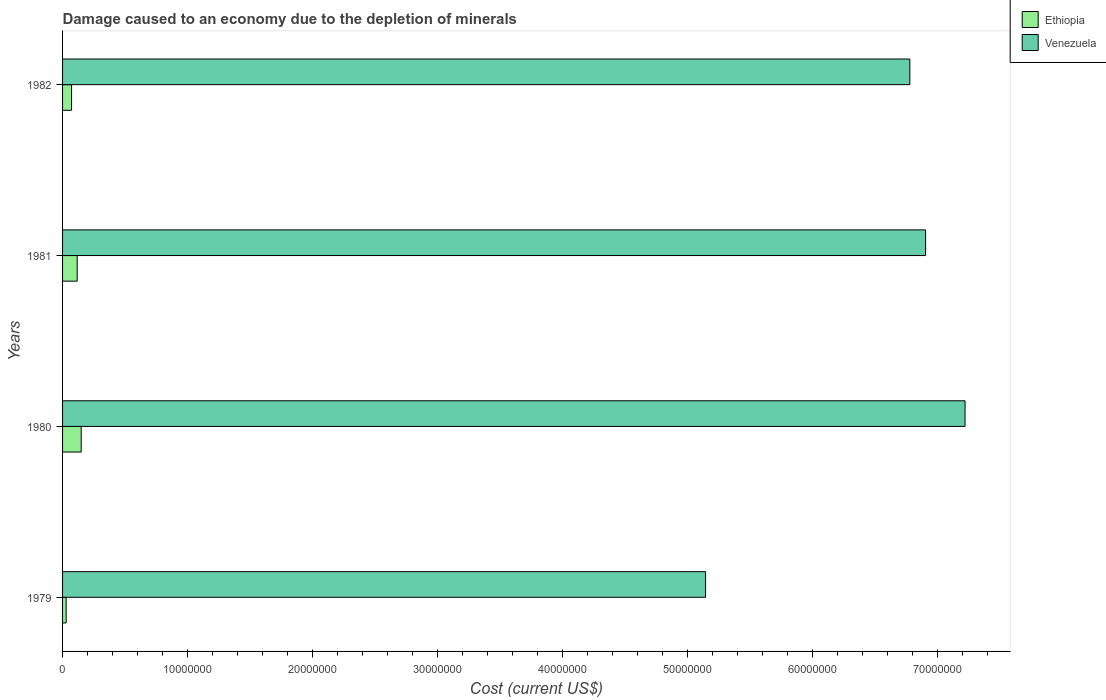Are the number of bars per tick equal to the number of legend labels?
Your response must be concise. Yes. Are the number of bars on each tick of the Y-axis equal?
Ensure brevity in your answer.  Yes. How many bars are there on the 4th tick from the top?
Ensure brevity in your answer.  2. What is the cost of damage caused due to the depletion of minerals in Venezuela in 1980?
Offer a very short reply. 7.22e+07. Across all years, what is the maximum cost of damage caused due to the depletion of minerals in Ethiopia?
Offer a terse response. 1.49e+06. Across all years, what is the minimum cost of damage caused due to the depletion of minerals in Venezuela?
Make the answer very short. 5.15e+07. In which year was the cost of damage caused due to the depletion of minerals in Venezuela minimum?
Give a very brief answer. 1979. What is the total cost of damage caused due to the depletion of minerals in Ethiopia in the graph?
Make the answer very short. 3.67e+06. What is the difference between the cost of damage caused due to the depletion of minerals in Venezuela in 1979 and that in 1980?
Offer a very short reply. -2.08e+07. What is the difference between the cost of damage caused due to the depletion of minerals in Ethiopia in 1979 and the cost of damage caused due to the depletion of minerals in Venezuela in 1980?
Offer a very short reply. -7.19e+07. What is the average cost of damage caused due to the depletion of minerals in Ethiopia per year?
Give a very brief answer. 9.18e+05. In the year 1982, what is the difference between the cost of damage caused due to the depletion of minerals in Venezuela and cost of damage caused due to the depletion of minerals in Ethiopia?
Offer a terse response. 6.71e+07. In how many years, is the cost of damage caused due to the depletion of minerals in Ethiopia greater than 62000000 US$?
Your answer should be very brief. 0. What is the ratio of the cost of damage caused due to the depletion of minerals in Ethiopia in 1980 to that in 1982?
Your answer should be very brief. 2.07. What is the difference between the highest and the second highest cost of damage caused due to the depletion of minerals in Venezuela?
Ensure brevity in your answer.  3.16e+06. What is the difference between the highest and the lowest cost of damage caused due to the depletion of minerals in Venezuela?
Offer a very short reply. 2.08e+07. In how many years, is the cost of damage caused due to the depletion of minerals in Venezuela greater than the average cost of damage caused due to the depletion of minerals in Venezuela taken over all years?
Provide a short and direct response. 3. What does the 1st bar from the top in 1979 represents?
Offer a terse response. Venezuela. What does the 2nd bar from the bottom in 1981 represents?
Your answer should be very brief. Venezuela. Are all the bars in the graph horizontal?
Your response must be concise. Yes. How many years are there in the graph?
Ensure brevity in your answer.  4. What is the title of the graph?
Your response must be concise. Damage caused to an economy due to the depletion of minerals. Does "Bermuda" appear as one of the legend labels in the graph?
Your response must be concise. No. What is the label or title of the X-axis?
Provide a succinct answer. Cost (current US$). What is the Cost (current US$) of Ethiopia in 1979?
Ensure brevity in your answer.  2.88e+05. What is the Cost (current US$) of Venezuela in 1979?
Provide a short and direct response. 5.15e+07. What is the Cost (current US$) in Ethiopia in 1980?
Provide a short and direct response. 1.49e+06. What is the Cost (current US$) in Venezuela in 1980?
Your response must be concise. 7.22e+07. What is the Cost (current US$) in Ethiopia in 1981?
Your response must be concise. 1.17e+06. What is the Cost (current US$) in Venezuela in 1981?
Make the answer very short. 6.91e+07. What is the Cost (current US$) in Ethiopia in 1982?
Offer a terse response. 7.20e+05. What is the Cost (current US$) in Venezuela in 1982?
Provide a short and direct response. 6.78e+07. Across all years, what is the maximum Cost (current US$) of Ethiopia?
Offer a terse response. 1.49e+06. Across all years, what is the maximum Cost (current US$) of Venezuela?
Offer a very short reply. 7.22e+07. Across all years, what is the minimum Cost (current US$) in Ethiopia?
Your answer should be very brief. 2.88e+05. Across all years, what is the minimum Cost (current US$) of Venezuela?
Offer a very short reply. 5.15e+07. What is the total Cost (current US$) in Ethiopia in the graph?
Offer a very short reply. 3.67e+06. What is the total Cost (current US$) of Venezuela in the graph?
Keep it short and to the point. 2.61e+08. What is the difference between the Cost (current US$) of Ethiopia in 1979 and that in 1980?
Give a very brief answer. -1.20e+06. What is the difference between the Cost (current US$) of Venezuela in 1979 and that in 1980?
Keep it short and to the point. -2.08e+07. What is the difference between the Cost (current US$) of Ethiopia in 1979 and that in 1981?
Offer a very short reply. -8.82e+05. What is the difference between the Cost (current US$) in Venezuela in 1979 and that in 1981?
Keep it short and to the point. -1.76e+07. What is the difference between the Cost (current US$) in Ethiopia in 1979 and that in 1982?
Your response must be concise. -4.33e+05. What is the difference between the Cost (current US$) in Venezuela in 1979 and that in 1982?
Your response must be concise. -1.63e+07. What is the difference between the Cost (current US$) in Ethiopia in 1980 and that in 1981?
Provide a short and direct response. 3.22e+05. What is the difference between the Cost (current US$) of Venezuela in 1980 and that in 1981?
Provide a succinct answer. 3.16e+06. What is the difference between the Cost (current US$) in Ethiopia in 1980 and that in 1982?
Your response must be concise. 7.72e+05. What is the difference between the Cost (current US$) of Venezuela in 1980 and that in 1982?
Ensure brevity in your answer.  4.42e+06. What is the difference between the Cost (current US$) of Ethiopia in 1981 and that in 1982?
Make the answer very short. 4.50e+05. What is the difference between the Cost (current US$) in Venezuela in 1981 and that in 1982?
Offer a very short reply. 1.26e+06. What is the difference between the Cost (current US$) in Ethiopia in 1979 and the Cost (current US$) in Venezuela in 1980?
Keep it short and to the point. -7.19e+07. What is the difference between the Cost (current US$) in Ethiopia in 1979 and the Cost (current US$) in Venezuela in 1981?
Your answer should be very brief. -6.88e+07. What is the difference between the Cost (current US$) of Ethiopia in 1979 and the Cost (current US$) of Venezuela in 1982?
Keep it short and to the point. -6.75e+07. What is the difference between the Cost (current US$) in Ethiopia in 1980 and the Cost (current US$) in Venezuela in 1981?
Provide a short and direct response. -6.76e+07. What is the difference between the Cost (current US$) in Ethiopia in 1980 and the Cost (current US$) in Venezuela in 1982?
Your response must be concise. -6.63e+07. What is the difference between the Cost (current US$) of Ethiopia in 1981 and the Cost (current US$) of Venezuela in 1982?
Make the answer very short. -6.66e+07. What is the average Cost (current US$) of Ethiopia per year?
Make the answer very short. 9.18e+05. What is the average Cost (current US$) of Venezuela per year?
Give a very brief answer. 6.51e+07. In the year 1979, what is the difference between the Cost (current US$) in Ethiopia and Cost (current US$) in Venezuela?
Provide a succinct answer. -5.12e+07. In the year 1980, what is the difference between the Cost (current US$) of Ethiopia and Cost (current US$) of Venezuela?
Make the answer very short. -7.07e+07. In the year 1981, what is the difference between the Cost (current US$) in Ethiopia and Cost (current US$) in Venezuela?
Your response must be concise. -6.79e+07. In the year 1982, what is the difference between the Cost (current US$) in Ethiopia and Cost (current US$) in Venezuela?
Keep it short and to the point. -6.71e+07. What is the ratio of the Cost (current US$) of Ethiopia in 1979 to that in 1980?
Provide a succinct answer. 0.19. What is the ratio of the Cost (current US$) in Venezuela in 1979 to that in 1980?
Offer a very short reply. 0.71. What is the ratio of the Cost (current US$) of Ethiopia in 1979 to that in 1981?
Your answer should be compact. 0.25. What is the ratio of the Cost (current US$) of Venezuela in 1979 to that in 1981?
Your response must be concise. 0.75. What is the ratio of the Cost (current US$) of Ethiopia in 1979 to that in 1982?
Ensure brevity in your answer.  0.4. What is the ratio of the Cost (current US$) in Venezuela in 1979 to that in 1982?
Keep it short and to the point. 0.76. What is the ratio of the Cost (current US$) of Ethiopia in 1980 to that in 1981?
Give a very brief answer. 1.28. What is the ratio of the Cost (current US$) of Venezuela in 1980 to that in 1981?
Provide a short and direct response. 1.05. What is the ratio of the Cost (current US$) in Ethiopia in 1980 to that in 1982?
Ensure brevity in your answer.  2.07. What is the ratio of the Cost (current US$) of Venezuela in 1980 to that in 1982?
Make the answer very short. 1.07. What is the ratio of the Cost (current US$) of Ethiopia in 1981 to that in 1982?
Offer a terse response. 1.62. What is the ratio of the Cost (current US$) of Venezuela in 1981 to that in 1982?
Your response must be concise. 1.02. What is the difference between the highest and the second highest Cost (current US$) in Ethiopia?
Provide a succinct answer. 3.22e+05. What is the difference between the highest and the second highest Cost (current US$) of Venezuela?
Provide a short and direct response. 3.16e+06. What is the difference between the highest and the lowest Cost (current US$) in Ethiopia?
Offer a very short reply. 1.20e+06. What is the difference between the highest and the lowest Cost (current US$) of Venezuela?
Offer a terse response. 2.08e+07. 